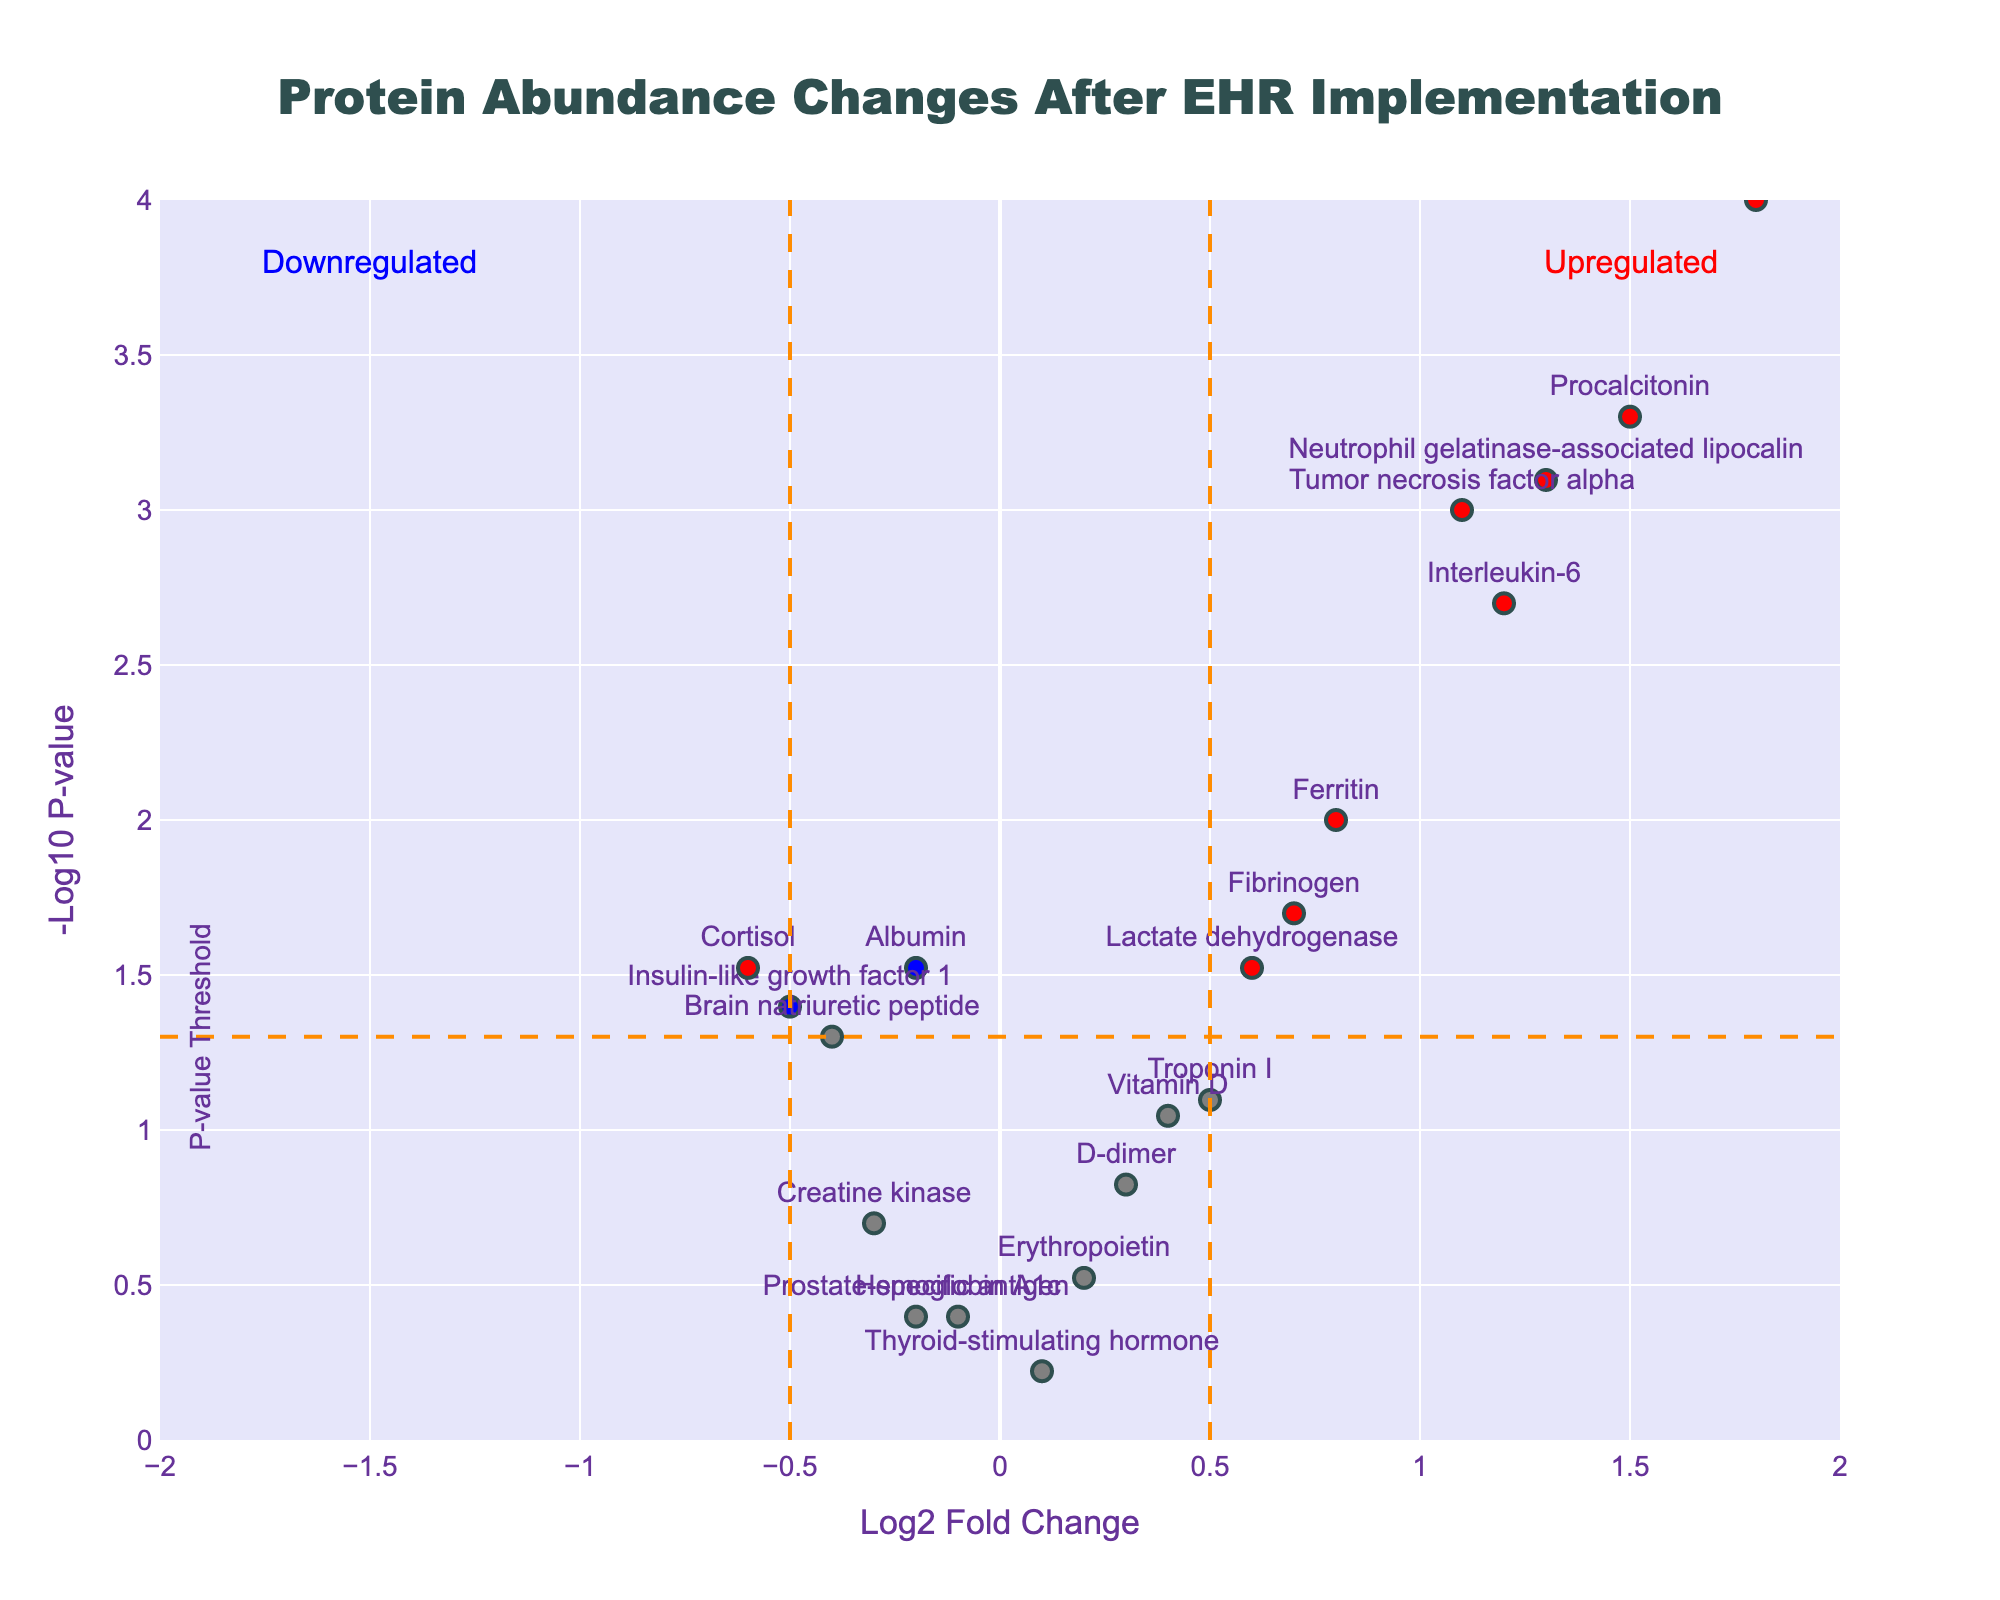What's the main title of the figure? The main title is found at the top center of the figure. It reads "Protein Abundance Changes After EHR Implementation".
Answer: Protein Abundance Changes After EHR Implementation What are the axes titles in the figure? The titles of the axes are located along the axes. The x-axis is titled "Log2 Fold Change", and the y-axis is titled "-Log10 P-value".
Answer: Log2 Fold Change and -Log10 P-value How many proteins are significantly upregulated after the implementation of the EHR system? Significantly upregulated proteins are those shown in red and are located on the right side of the plot (positive fold change) and above the horizontal dashed line (p-value < 0.05).
Answer: 7 Which protein has the smallest p-value and what is its significance color? The protein with the smallest p-value is located highest on the y-axis. The one with the highest -Log10 value (y-axis value) is C-reactive protein, located in the red category.
Answer: C-reactive protein, red Are there any proteins that are significantly downregulated after the implementation? If so, how many? Significantly downregulated proteins are shown in blue or red and are located on the left side of the plot (negative fold change) and above the horizontal dashed line. Count those only.
Answer: 2 Which protein has the most positive fold change and where is it positioned in the plot? Identify the data point farthest to the right (most positive x-axis value) which corresponds to Procalcitonin. It is positioned on the right side above the significance line.
Answer: Procalcitonin, right side above significance line What does the color blue indicate about the proteins in the plot? Blue indicates proteins that have a p-value < 0.05 (above the horizontal dashed line) but have an absolute fold change ≤ 0.5 (close to the center vertical axis).
Answer: Significantly changed but low fold change Based on the plot, name a protein that did not show a significant change and describe its position. Proteins that are not significantly changed have their data points below the horizontal dashed line or close to the vertical axis. Albumin is an example and is positioned to the left below the significance line.
Answer: Albumin, left below significance line How many proteins have a log2 fold change greater than 1 and are statistically significant? List their names. Check for data points to the right of 1 on the x-axis and above the significance line. These proteins are C-reactive protein, Interleukin-6, Procalcitonin, and Tumor necrosis factor alpha.
Answer: 4, C-reactive protein, Interleukin-6, Procalcitonin, Tumor necrosis factor alpha Is the protein Insulin-like growth factor 1 significantly downregulated, and how can you tell? To determine significance, look for points above the horizontal dashed line. Insulin-like growth factor 1 is downregulated (negative fold change) but not above the significance line, so it is not significantly downregulated.
Answer: No 